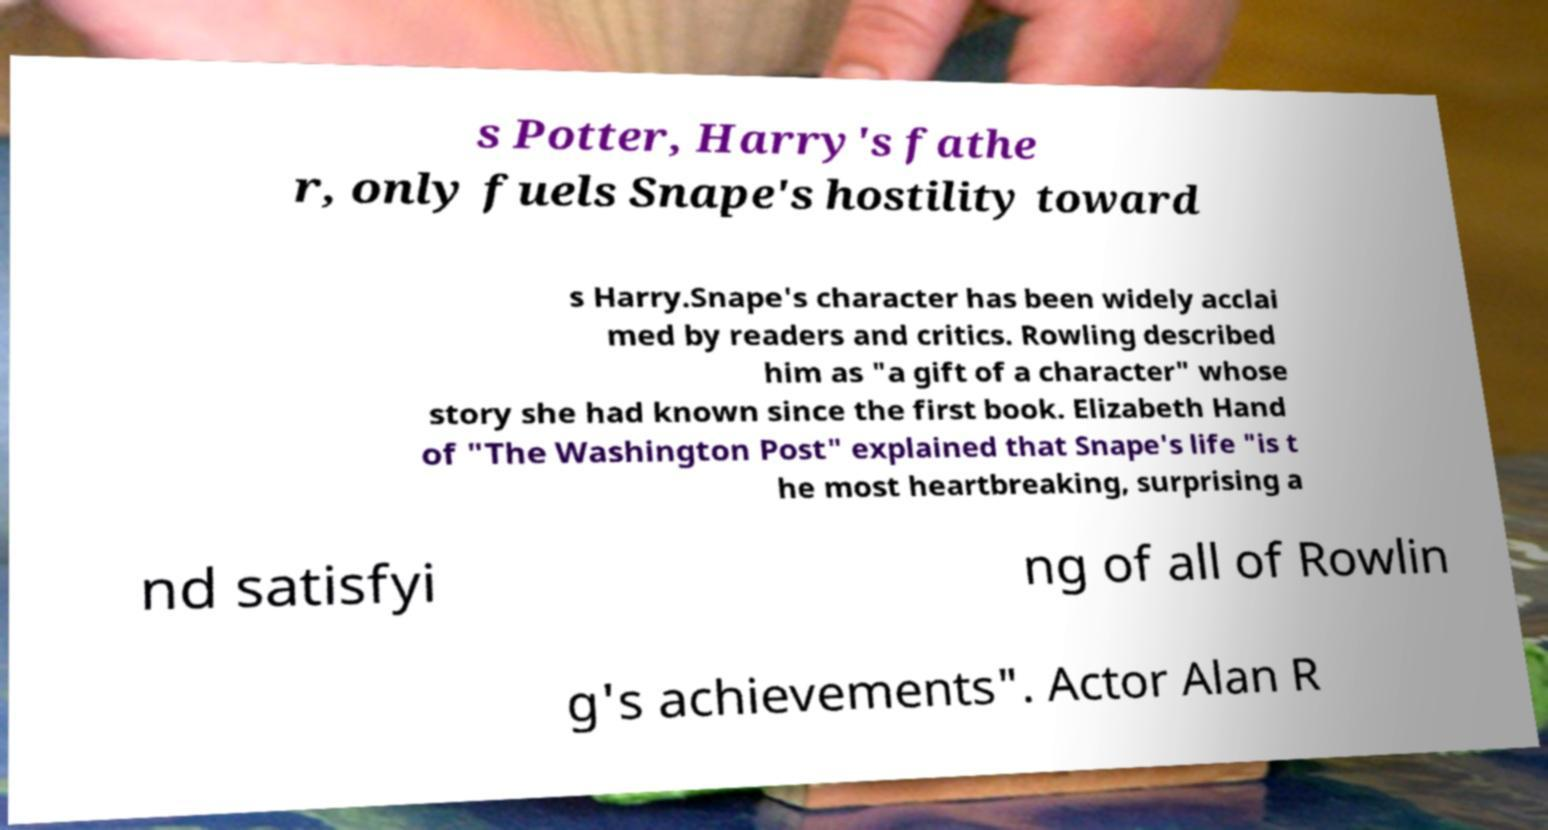Could you extract and type out the text from this image? s Potter, Harry's fathe r, only fuels Snape's hostility toward s Harry.Snape's character has been widely acclai med by readers and critics. Rowling described him as "a gift of a character" whose story she had known since the first book. Elizabeth Hand of "The Washington Post" explained that Snape's life "is t he most heartbreaking, surprising a nd satisfyi ng of all of Rowlin g's achievements". Actor Alan R 